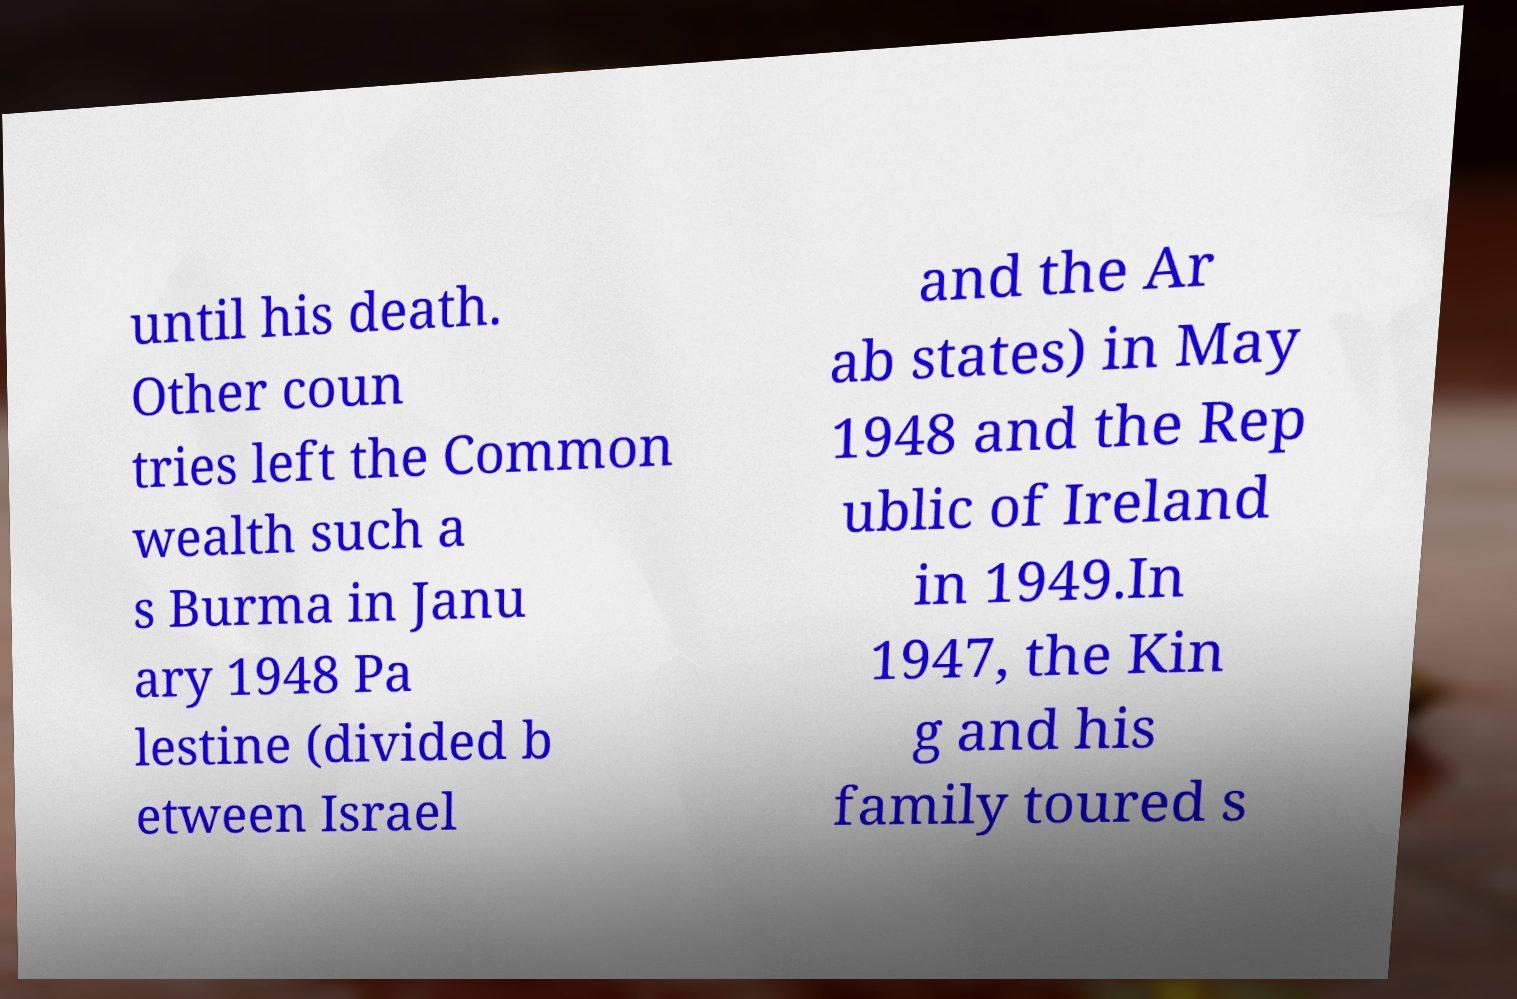I need the written content from this picture converted into text. Can you do that? until his death. Other coun tries left the Common wealth such a s Burma in Janu ary 1948 Pa lestine (divided b etween Israel and the Ar ab states) in May 1948 and the Rep ublic of Ireland in 1949.In 1947, the Kin g and his family toured s 